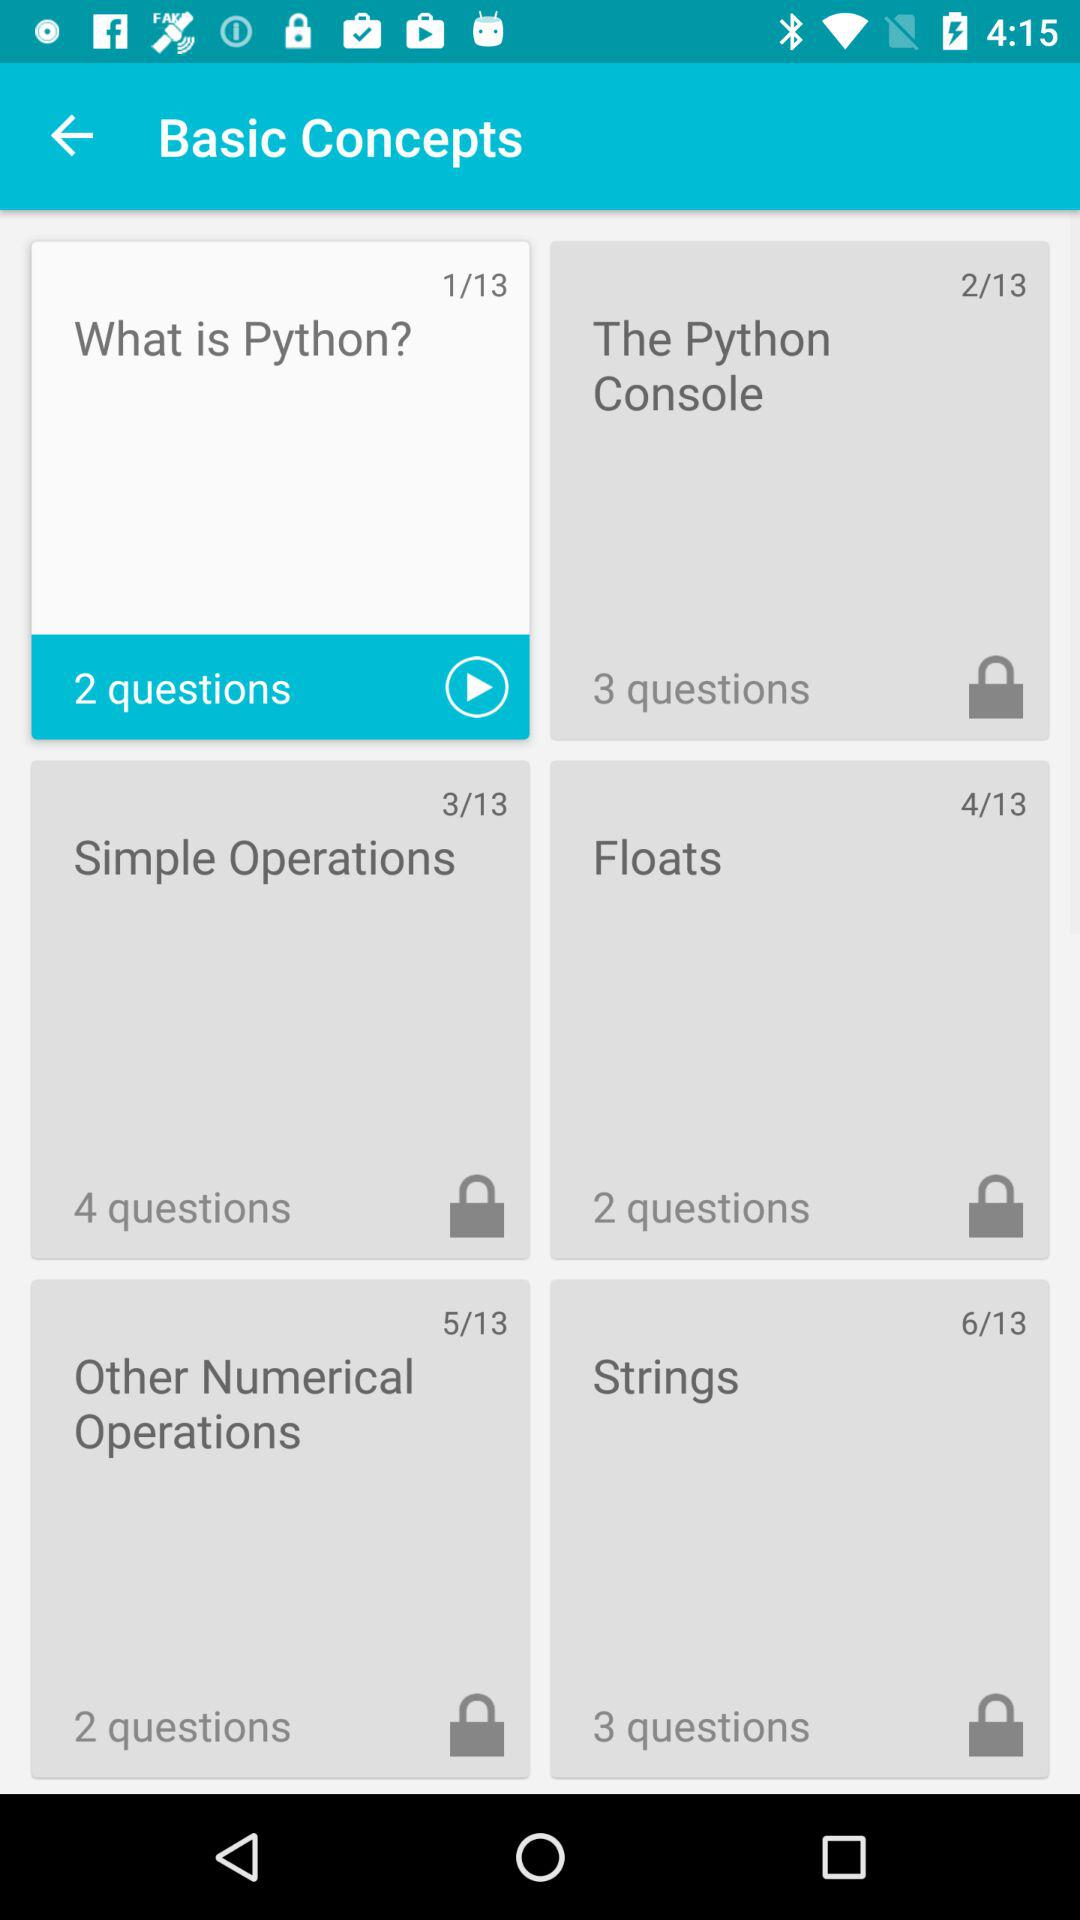What is the name of slide 3? The name of slide 3 is "Simple Operations". 